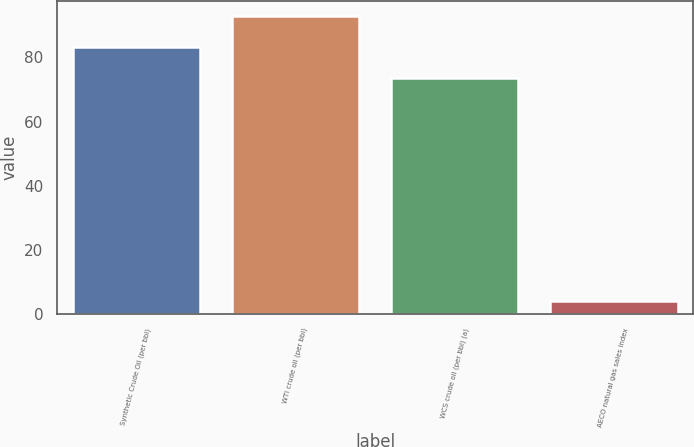Convert chart. <chart><loc_0><loc_0><loc_500><loc_500><bar_chart><fcel>Synthetic Crude Oil (per bbl)<fcel>WTI crude oil (per bbl)<fcel>WCS crude oil (per bbl) (a)<fcel>AECO natural gas sales index<nl><fcel>83.35<fcel>92.91<fcel>73.6<fcel>3.99<nl></chart> 